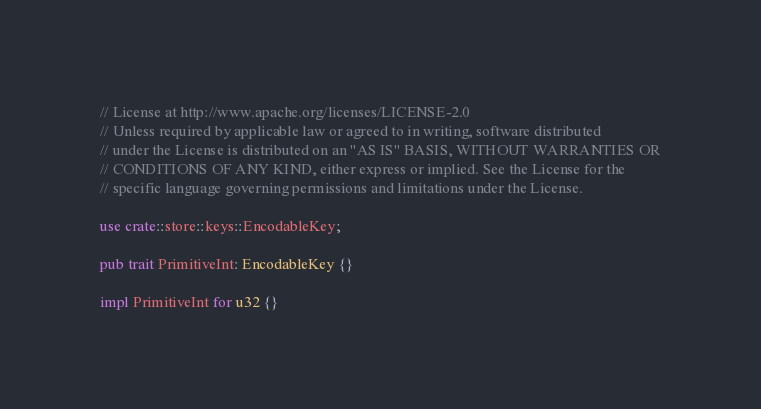Convert code to text. <code><loc_0><loc_0><loc_500><loc_500><_Rust_>// License at http://www.apache.org/licenses/LICENSE-2.0
// Unless required by applicable law or agreed to in writing, software distributed
// under the License is distributed on an "AS IS" BASIS, WITHOUT WARRANTIES OR
// CONDITIONS OF ANY KIND, either express or implied. See the License for the
// specific language governing permissions and limitations under the License.

use crate::store::keys::EncodableKey;

pub trait PrimitiveInt: EncodableKey {}

impl PrimitiveInt for u32 {}
</code> 